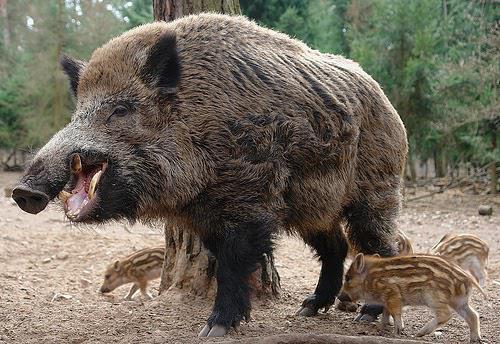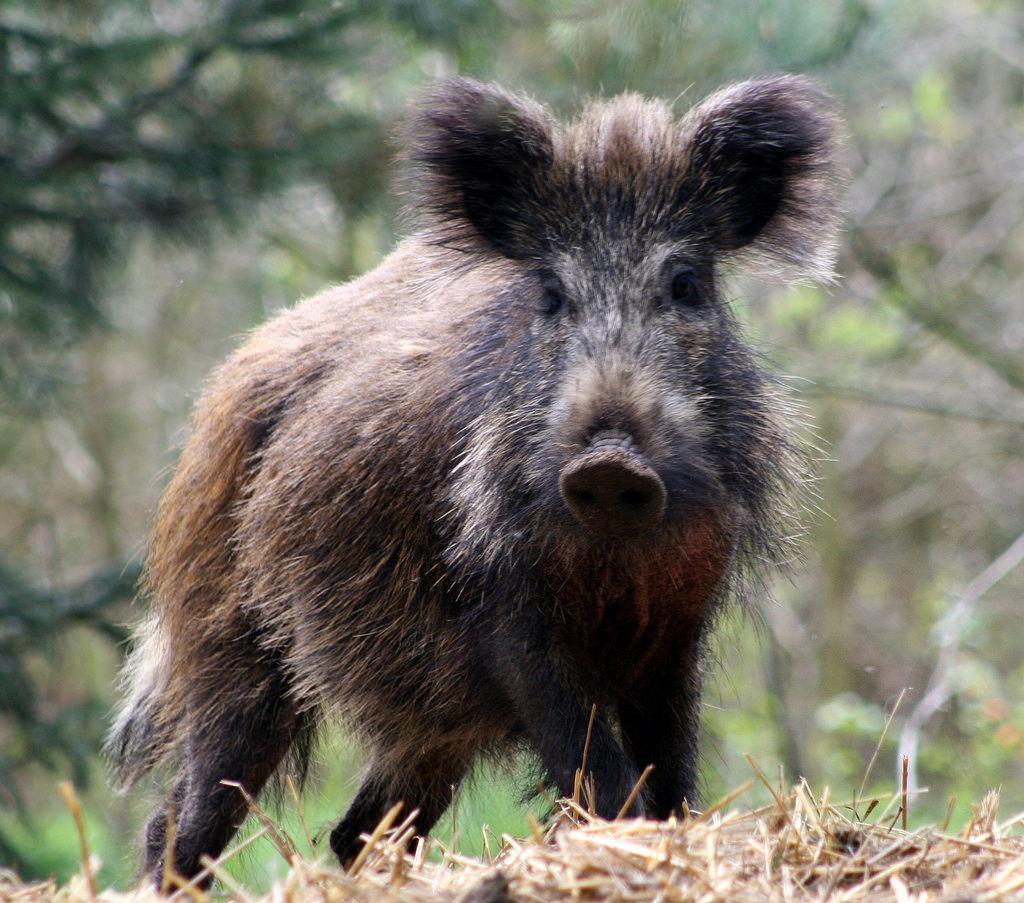The first image is the image on the left, the second image is the image on the right. Evaluate the accuracy of this statement regarding the images: "There are baby boars in the image on the left.". Is it true? Answer yes or no. Yes. 